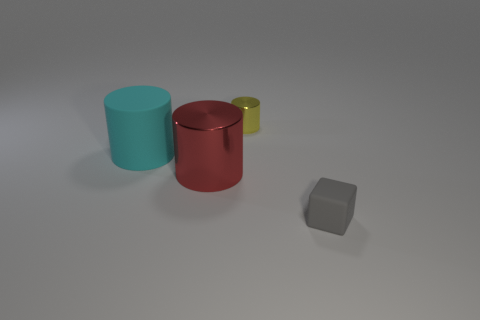Subtract all yellow metal cylinders. How many cylinders are left? 2 Add 3 large cyan cylinders. How many objects exist? 7 Subtract all cylinders. How many objects are left? 1 Subtract all brown cylinders. Subtract all red cubes. How many cylinders are left? 3 Subtract 0 green cylinders. How many objects are left? 4 Subtract all red metal objects. Subtract all tiny gray metal blocks. How many objects are left? 3 Add 4 yellow cylinders. How many yellow cylinders are left? 5 Add 3 rubber things. How many rubber things exist? 5 